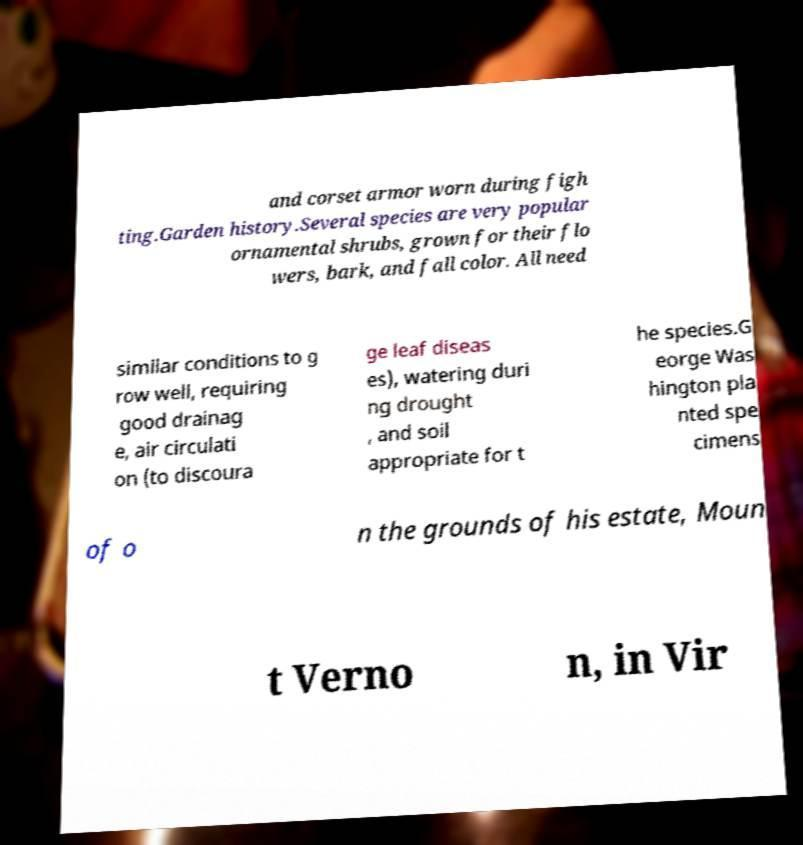I need the written content from this picture converted into text. Can you do that? and corset armor worn during figh ting.Garden history.Several species are very popular ornamental shrubs, grown for their flo wers, bark, and fall color. All need similar conditions to g row well, requiring good drainag e, air circulati on (to discoura ge leaf diseas es), watering duri ng drought , and soil appropriate for t he species.G eorge Was hington pla nted spe cimens of o n the grounds of his estate, Moun t Verno n, in Vir 